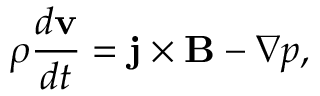Convert formula to latex. <formula><loc_0><loc_0><loc_500><loc_500>\rho \frac { d { v } } { d t } = j \times B - \nabla p ,</formula> 